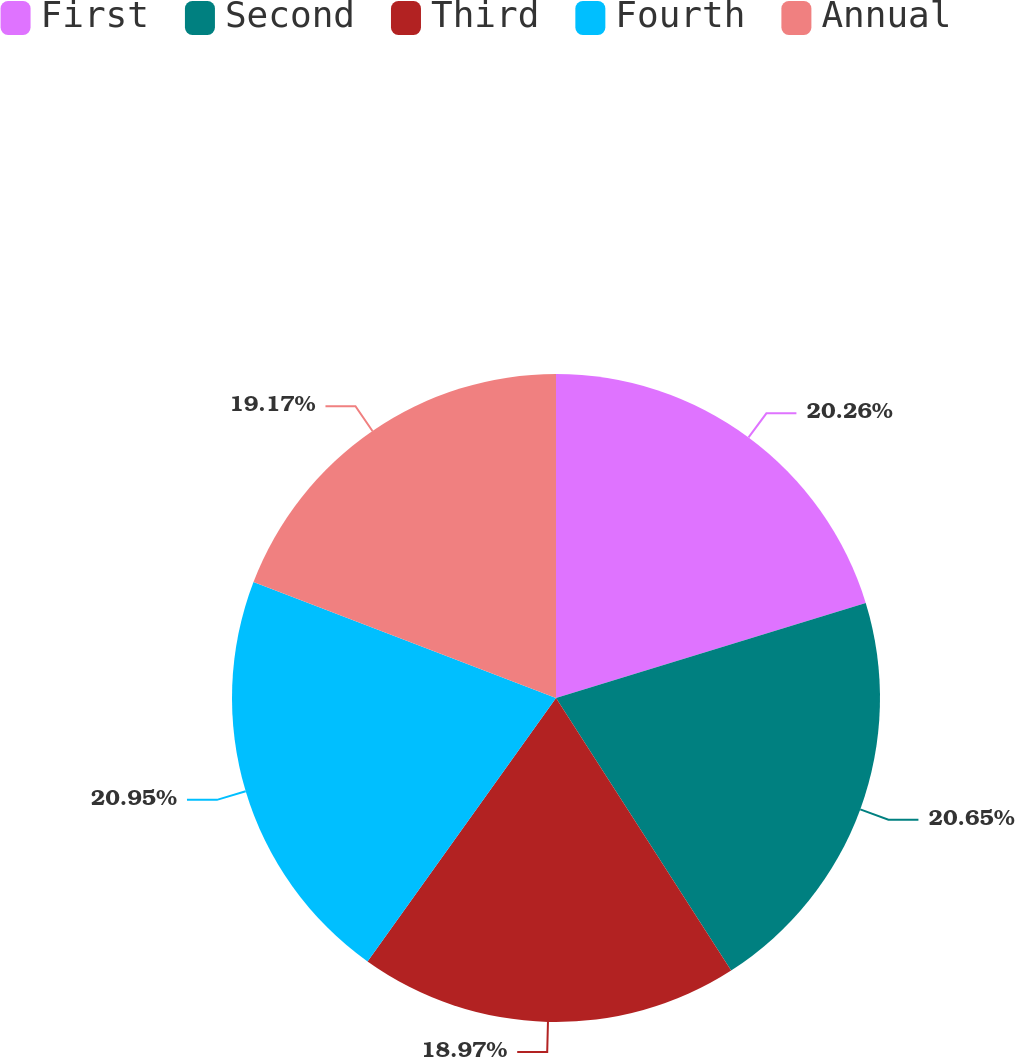Convert chart. <chart><loc_0><loc_0><loc_500><loc_500><pie_chart><fcel>First<fcel>Second<fcel>Third<fcel>Fourth<fcel>Annual<nl><fcel>20.26%<fcel>20.65%<fcel>18.97%<fcel>20.95%<fcel>19.17%<nl></chart> 